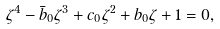Convert formula to latex. <formula><loc_0><loc_0><loc_500><loc_500>\zeta ^ { 4 } - \bar { b } _ { 0 } \zeta ^ { 3 } + c _ { 0 } \zeta ^ { 2 } + b _ { 0 } \zeta + 1 = 0 ,</formula> 